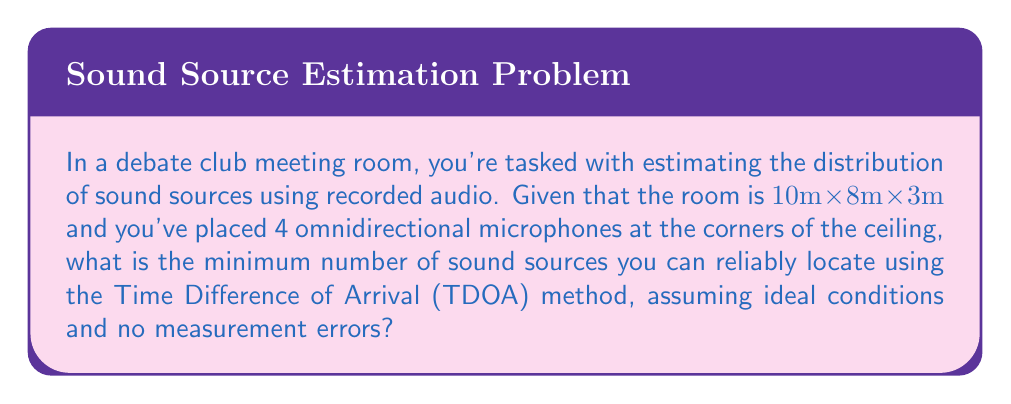Could you help me with this problem? To solve this problem, we need to understand the principles of source localization using the Time Difference of Arrival (TDOA) method:

1. TDOA requires at least 3 microphones to locate a single sound source in 3D space.

2. Each microphone pair provides a hyperbolic surface of possible source locations.

3. The intersection of these surfaces gives the source location.

4. For $n$ microphones, we can form $\binom{n}{2} = \frac{n(n-1)}{2}$ unique pairs.

5. In our case, with 4 microphones, we have $\binom{4}{2} = 6$ unique pairs.

6. Each pair provides one equation, so we have 6 equations.

7. To locate a sound source in 3D space, we need 3 unknowns (x, y, z coordinates).

8. The number of sources we can locate is the integer part of $\frac{\text{number of equations}}{3}$.

Therefore, the minimum number of sound sources we can reliably locate is:

$$\left\lfloor\frac{6}{3}\right\rfloor = 2$$

Where $\lfloor \cdot \rfloor$ denotes the floor function.
Answer: 2 sound sources 